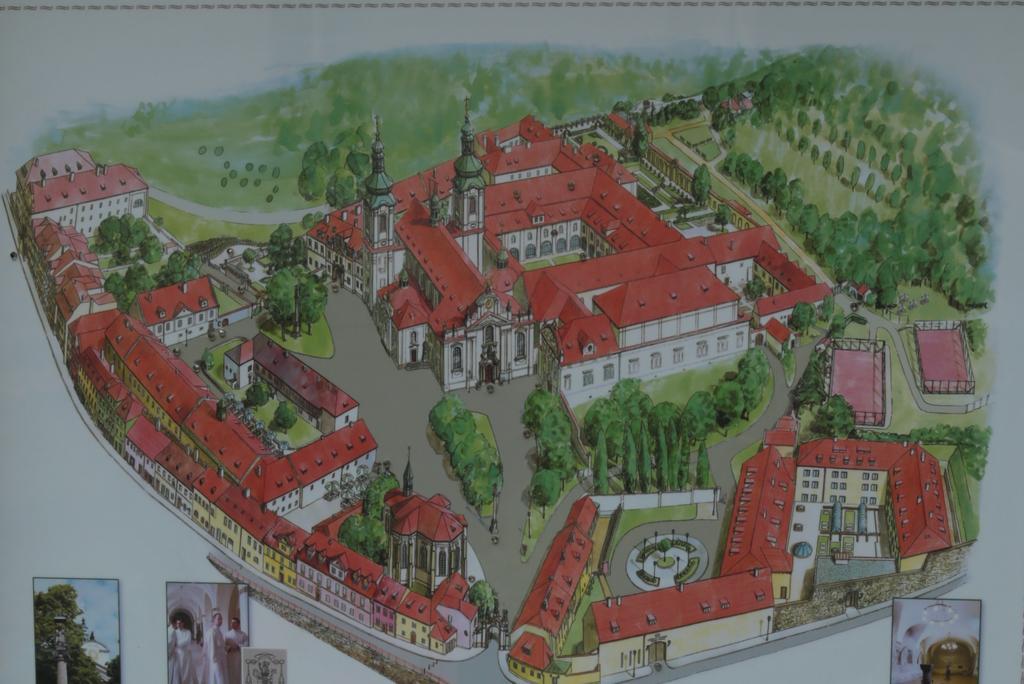Can you describe this image briefly? It is a painting. Here there are so many houses, trees, grass, windows, walls and roads. At the bottom, of the image, we can see a few pictures. 